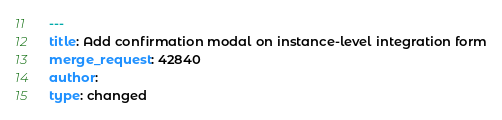<code> <loc_0><loc_0><loc_500><loc_500><_YAML_>---
title: Add confirmation modal on instance-level integration form
merge_request: 42840
author:
type: changed
</code> 